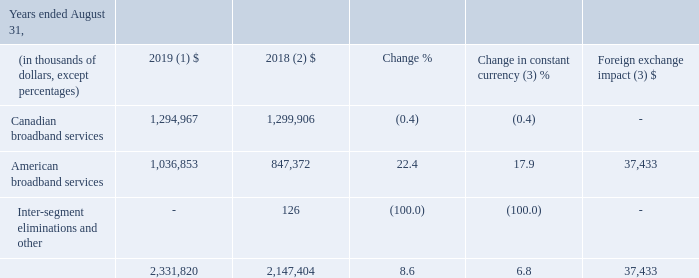REVENUE
(1) Fiscal 2019 average foreign exchange rate used for translation was 1.3255 USD/CDN.
(2) Fiscal 2018 was restated to comply with IFRS 15 and to reflect a change in accounting policy as well as to reclassify results from Cogeco Peer 1 as discontinued operations. For further details, please consult the "Accounting policies" and "Discontinued operations" sections.
(3) Fiscal 2019 actuals are translated at the average foreign exchange rate of fiscal 2018 which was 1.2773 USD/CDN.
Fiscal 2019 revenue increased by 8.6% (6.8% in constant currency) resulting from: • a growth in the American broadband services segment mainly due to the impact of the MetroCast acquisition which was included in revenue for only an eight-month period in the prior year combined with strong organic growth and the acquisition of the south Florida fibre network previously owned by FiberLight, LLC (the "FiberLight acquisition"); partly offset by • a decrease in the Canadian broadband services segment mainly as a result of: ◦ a decline in primary service units in the fourth quarter of fiscal 2018 and the first quarter of 2019 from lower service activations primarily due to issues resulting from the implementation of a new customer management system; partly offset by ◦ rate increases; and ◦ higher net pricing from consumer sales.
For further details on the Corporation’s revenue, please refer to the "Segmented operating and financial results" section.
What was the average foreign exchange rate of fiscal 2018? 1.2773 usd/cdn. What caused the decrease in the Canadian broadband services segment? A decline in primary service units in the fourth quarter of fiscal 2018 and the first quarter of 2019 from lower service activations primarily due to issues resulting from the implementation of a new customer management system; partly offset by ◦ rate increases; and ◦ higher net pricing from consumer sales. What was the Canadian broadband services in 2019?
Answer scale should be: million. 1,294,967. What is the increase / (decrease) in Canadian broadband services from 2018 to 2019?
Answer scale should be: million. 1,294,967 - 1,299,906
Answer: -4939. What was the average American broadband services between 2018 and 2019?
Answer scale should be: million. (1,036,853 + 847,372) / 2
Answer: 942112.5. What was the increase / (decrease) of Inter-segment eliminations and other from 2018 to 2019?
Answer scale should be: million. 0 - 126
Answer: -126. 